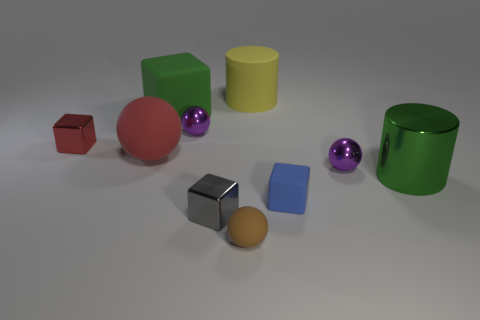Are there any yellow rubber cylinders in front of the big green metallic thing?
Give a very brief answer. No. Are there any cylinders that are behind the shiny object on the left side of the green matte object?
Provide a succinct answer. Yes. There is a purple sphere to the right of the tiny rubber sphere; does it have the same size as the matte block on the left side of the tiny matte sphere?
Offer a very short reply. No. How many small things are yellow cylinders or green cylinders?
Your response must be concise. 0. What material is the purple sphere in front of the metallic ball that is on the left side of the brown object made of?
Keep it short and to the point. Metal. What is the shape of the object that is the same color as the large block?
Your answer should be compact. Cylinder. Are there any yellow cylinders made of the same material as the big red sphere?
Your answer should be very brief. Yes. Do the small red thing and the tiny purple object that is right of the big yellow matte thing have the same material?
Offer a terse response. Yes. There is a ball that is the same size as the green matte thing; what is its color?
Your answer should be compact. Red. What size is the green object that is right of the small brown rubber ball that is on the right side of the tiny gray metallic thing?
Keep it short and to the point. Large. 